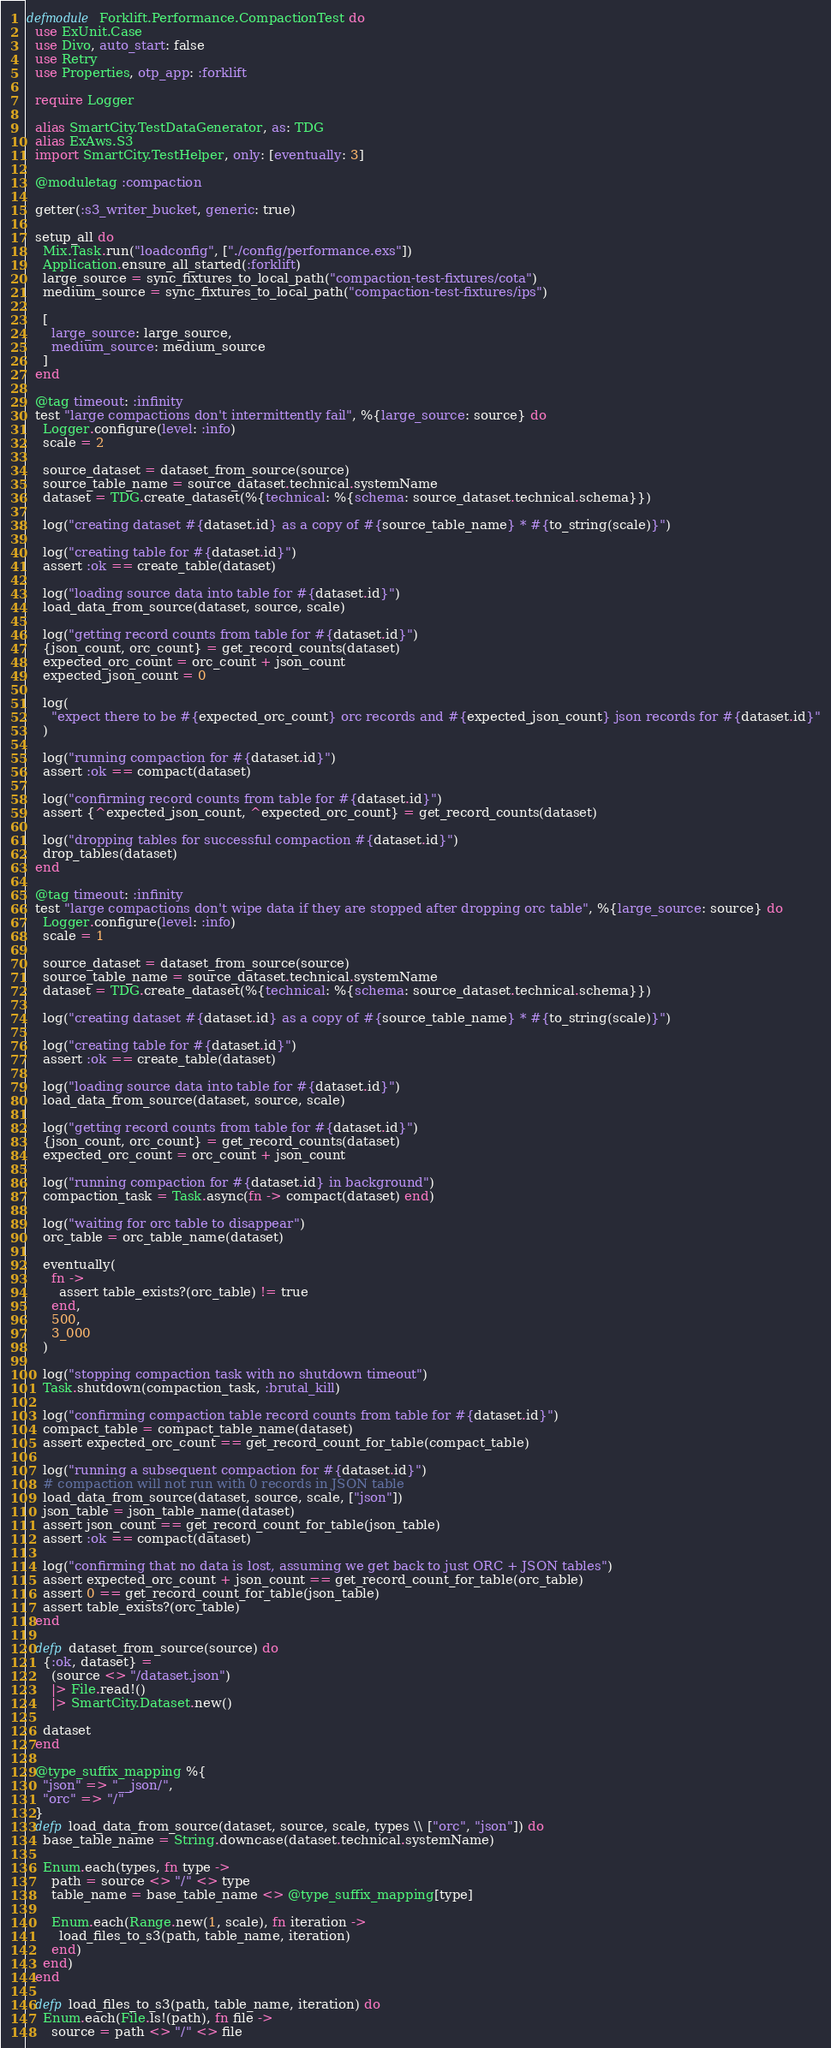<code> <loc_0><loc_0><loc_500><loc_500><_Elixir_>defmodule Forklift.Performance.CompactionTest do
  use ExUnit.Case
  use Divo, auto_start: false
  use Retry
  use Properties, otp_app: :forklift

  require Logger

  alias SmartCity.TestDataGenerator, as: TDG
  alias ExAws.S3
  import SmartCity.TestHelper, only: [eventually: 3]

  @moduletag :compaction

  getter(:s3_writer_bucket, generic: true)

  setup_all do
    Mix.Task.run("loadconfig", ["./config/performance.exs"])
    Application.ensure_all_started(:forklift)
    large_source = sync_fixtures_to_local_path("compaction-test-fixtures/cota")
    medium_source = sync_fixtures_to_local_path("compaction-test-fixtures/ips")

    [
      large_source: large_source,
      medium_source: medium_source
    ]
  end

  @tag timeout: :infinity
  test "large compactions don't intermittently fail", %{large_source: source} do
    Logger.configure(level: :info)
    scale = 2

    source_dataset = dataset_from_source(source)
    source_table_name = source_dataset.technical.systemName
    dataset = TDG.create_dataset(%{technical: %{schema: source_dataset.technical.schema}})

    log("creating dataset #{dataset.id} as a copy of #{source_table_name} * #{to_string(scale)}")

    log("creating table for #{dataset.id}")
    assert :ok == create_table(dataset)

    log("loading source data into table for #{dataset.id}")
    load_data_from_source(dataset, source, scale)

    log("getting record counts from table for #{dataset.id}")
    {json_count, orc_count} = get_record_counts(dataset)
    expected_orc_count = orc_count + json_count
    expected_json_count = 0

    log(
      "expect there to be #{expected_orc_count} orc records and #{expected_json_count} json records for #{dataset.id}"
    )

    log("running compaction for #{dataset.id}")
    assert :ok == compact(dataset)

    log("confirming record counts from table for #{dataset.id}")
    assert {^expected_json_count, ^expected_orc_count} = get_record_counts(dataset)

    log("dropping tables for successful compaction #{dataset.id}")
    drop_tables(dataset)
  end

  @tag timeout: :infinity
  test "large compactions don't wipe data if they are stopped after dropping orc table", %{large_source: source} do
    Logger.configure(level: :info)
    scale = 1

    source_dataset = dataset_from_source(source)
    source_table_name = source_dataset.technical.systemName
    dataset = TDG.create_dataset(%{technical: %{schema: source_dataset.technical.schema}})

    log("creating dataset #{dataset.id} as a copy of #{source_table_name} * #{to_string(scale)}")

    log("creating table for #{dataset.id}")
    assert :ok == create_table(dataset)

    log("loading source data into table for #{dataset.id}")
    load_data_from_source(dataset, source, scale)

    log("getting record counts from table for #{dataset.id}")
    {json_count, orc_count} = get_record_counts(dataset)
    expected_orc_count = orc_count + json_count

    log("running compaction for #{dataset.id} in background")
    compaction_task = Task.async(fn -> compact(dataset) end)

    log("waiting for orc table to disappear")
    orc_table = orc_table_name(dataset)

    eventually(
      fn ->
        assert table_exists?(orc_table) != true
      end,
      500,
      3_000
    )

    log("stopping compaction task with no shutdown timeout")
    Task.shutdown(compaction_task, :brutal_kill)

    log("confirming compaction table record counts from table for #{dataset.id}")
    compact_table = compact_table_name(dataset)
    assert expected_orc_count == get_record_count_for_table(compact_table)

    log("running a subsequent compaction for #{dataset.id}")
    # compaction will not run with 0 records in JSON table
    load_data_from_source(dataset, source, scale, ["json"])
    json_table = json_table_name(dataset)
    assert json_count == get_record_count_for_table(json_table)
    assert :ok == compact(dataset)

    log("confirming that no data is lost, assuming we get back to just ORC + JSON tables")
    assert expected_orc_count + json_count == get_record_count_for_table(orc_table)
    assert 0 == get_record_count_for_table(json_table)
    assert table_exists?(orc_table)
  end

  defp dataset_from_source(source) do
    {:ok, dataset} =
      (source <> "/dataset.json")
      |> File.read!()
      |> SmartCity.Dataset.new()

    dataset
  end

  @type_suffix_mapping %{
    "json" => "__json/",
    "orc" => "/"
  }
  defp load_data_from_source(dataset, source, scale, types \\ ["orc", "json"]) do
    base_table_name = String.downcase(dataset.technical.systemName)

    Enum.each(types, fn type ->
      path = source <> "/" <> type
      table_name = base_table_name <> @type_suffix_mapping[type]

      Enum.each(Range.new(1, scale), fn iteration ->
        load_files_to_s3(path, table_name, iteration)
      end)
    end)
  end

  defp load_files_to_s3(path, table_name, iteration) do
    Enum.each(File.ls!(path), fn file ->
      source = path <> "/" <> file</code> 